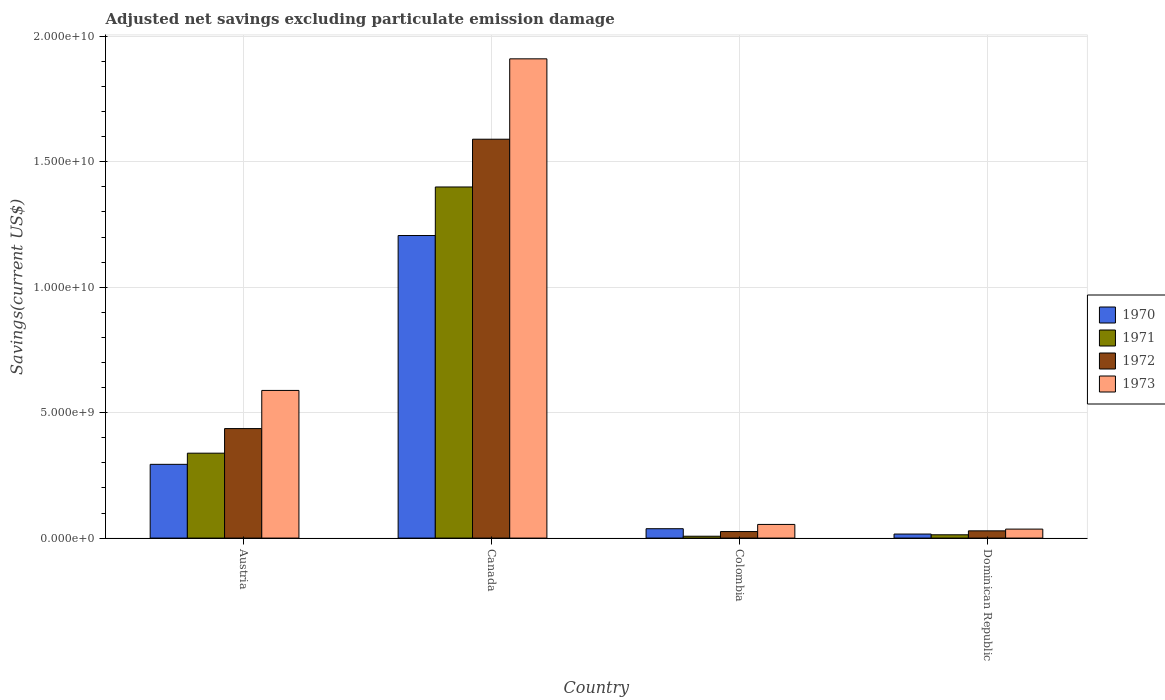How many bars are there on the 2nd tick from the right?
Ensure brevity in your answer.  4. What is the label of the 4th group of bars from the left?
Offer a very short reply. Dominican Republic. In how many cases, is the number of bars for a given country not equal to the number of legend labels?
Offer a terse response. 0. What is the adjusted net savings in 1970 in Dominican Republic?
Ensure brevity in your answer.  1.61e+08. Across all countries, what is the maximum adjusted net savings in 1972?
Your answer should be very brief. 1.59e+1. Across all countries, what is the minimum adjusted net savings in 1972?
Give a very brief answer. 2.60e+08. In which country was the adjusted net savings in 1972 maximum?
Keep it short and to the point. Canada. What is the total adjusted net savings in 1970 in the graph?
Provide a short and direct response. 1.55e+1. What is the difference between the adjusted net savings in 1971 in Canada and that in Colombia?
Your answer should be very brief. 1.39e+1. What is the difference between the adjusted net savings in 1970 in Canada and the adjusted net savings in 1972 in Dominican Republic?
Offer a terse response. 1.18e+1. What is the average adjusted net savings in 1973 per country?
Your answer should be compact. 6.47e+09. What is the difference between the adjusted net savings of/in 1970 and adjusted net savings of/in 1973 in Austria?
Keep it short and to the point. -2.95e+09. In how many countries, is the adjusted net savings in 1972 greater than 1000000000 US$?
Offer a terse response. 2. What is the ratio of the adjusted net savings in 1973 in Colombia to that in Dominican Republic?
Provide a succinct answer. 1.52. Is the adjusted net savings in 1972 in Colombia less than that in Dominican Republic?
Give a very brief answer. Yes. Is the difference between the adjusted net savings in 1970 in Canada and Dominican Republic greater than the difference between the adjusted net savings in 1973 in Canada and Dominican Republic?
Provide a succinct answer. No. What is the difference between the highest and the second highest adjusted net savings in 1972?
Offer a terse response. 4.08e+09. What is the difference between the highest and the lowest adjusted net savings in 1971?
Your answer should be compact. 1.39e+1. In how many countries, is the adjusted net savings in 1971 greater than the average adjusted net savings in 1971 taken over all countries?
Make the answer very short. 1. Is the sum of the adjusted net savings in 1970 in Canada and Colombia greater than the maximum adjusted net savings in 1971 across all countries?
Your answer should be compact. No. What does the 4th bar from the left in Colombia represents?
Your answer should be compact. 1973. What does the 2nd bar from the right in Dominican Republic represents?
Offer a terse response. 1972. How many bars are there?
Your answer should be very brief. 16. Are all the bars in the graph horizontal?
Provide a succinct answer. No. Does the graph contain grids?
Keep it short and to the point. Yes. How many legend labels are there?
Your answer should be compact. 4. How are the legend labels stacked?
Provide a short and direct response. Vertical. What is the title of the graph?
Offer a very short reply. Adjusted net savings excluding particulate emission damage. What is the label or title of the Y-axis?
Ensure brevity in your answer.  Savings(current US$). What is the Savings(current US$) of 1970 in Austria?
Provide a short and direct response. 2.94e+09. What is the Savings(current US$) in 1971 in Austria?
Your answer should be very brief. 3.38e+09. What is the Savings(current US$) of 1972 in Austria?
Provide a short and direct response. 4.37e+09. What is the Savings(current US$) of 1973 in Austria?
Give a very brief answer. 5.89e+09. What is the Savings(current US$) of 1970 in Canada?
Provide a short and direct response. 1.21e+1. What is the Savings(current US$) of 1971 in Canada?
Make the answer very short. 1.40e+1. What is the Savings(current US$) in 1972 in Canada?
Your answer should be very brief. 1.59e+1. What is the Savings(current US$) of 1973 in Canada?
Give a very brief answer. 1.91e+1. What is the Savings(current US$) in 1970 in Colombia?
Ensure brevity in your answer.  3.74e+08. What is the Savings(current US$) of 1971 in Colombia?
Ensure brevity in your answer.  7.46e+07. What is the Savings(current US$) in 1972 in Colombia?
Offer a very short reply. 2.60e+08. What is the Savings(current US$) of 1973 in Colombia?
Your response must be concise. 5.45e+08. What is the Savings(current US$) in 1970 in Dominican Republic?
Your response must be concise. 1.61e+08. What is the Savings(current US$) of 1971 in Dominican Republic?
Keep it short and to the point. 1.32e+08. What is the Savings(current US$) in 1972 in Dominican Republic?
Your answer should be very brief. 2.89e+08. What is the Savings(current US$) in 1973 in Dominican Republic?
Make the answer very short. 3.58e+08. Across all countries, what is the maximum Savings(current US$) in 1970?
Provide a succinct answer. 1.21e+1. Across all countries, what is the maximum Savings(current US$) in 1971?
Provide a short and direct response. 1.40e+1. Across all countries, what is the maximum Savings(current US$) in 1972?
Ensure brevity in your answer.  1.59e+1. Across all countries, what is the maximum Savings(current US$) in 1973?
Your answer should be compact. 1.91e+1. Across all countries, what is the minimum Savings(current US$) in 1970?
Keep it short and to the point. 1.61e+08. Across all countries, what is the minimum Savings(current US$) in 1971?
Offer a terse response. 7.46e+07. Across all countries, what is the minimum Savings(current US$) of 1972?
Your answer should be very brief. 2.60e+08. Across all countries, what is the minimum Savings(current US$) of 1973?
Provide a succinct answer. 3.58e+08. What is the total Savings(current US$) in 1970 in the graph?
Provide a succinct answer. 1.55e+1. What is the total Savings(current US$) in 1971 in the graph?
Make the answer very short. 1.76e+1. What is the total Savings(current US$) in 1972 in the graph?
Offer a very short reply. 2.08e+1. What is the total Savings(current US$) in 1973 in the graph?
Your answer should be compact. 2.59e+1. What is the difference between the Savings(current US$) in 1970 in Austria and that in Canada?
Your response must be concise. -9.12e+09. What is the difference between the Savings(current US$) in 1971 in Austria and that in Canada?
Give a very brief answer. -1.06e+1. What is the difference between the Savings(current US$) of 1972 in Austria and that in Canada?
Ensure brevity in your answer.  -1.15e+1. What is the difference between the Savings(current US$) in 1973 in Austria and that in Canada?
Make the answer very short. -1.32e+1. What is the difference between the Savings(current US$) in 1970 in Austria and that in Colombia?
Offer a terse response. 2.57e+09. What is the difference between the Savings(current US$) of 1971 in Austria and that in Colombia?
Offer a very short reply. 3.31e+09. What is the difference between the Savings(current US$) of 1972 in Austria and that in Colombia?
Make the answer very short. 4.11e+09. What is the difference between the Savings(current US$) of 1973 in Austria and that in Colombia?
Keep it short and to the point. 5.34e+09. What is the difference between the Savings(current US$) in 1970 in Austria and that in Dominican Republic?
Give a very brief answer. 2.78e+09. What is the difference between the Savings(current US$) in 1971 in Austria and that in Dominican Republic?
Provide a succinct answer. 3.25e+09. What is the difference between the Savings(current US$) in 1972 in Austria and that in Dominican Republic?
Keep it short and to the point. 4.08e+09. What is the difference between the Savings(current US$) of 1973 in Austria and that in Dominican Republic?
Provide a short and direct response. 5.53e+09. What is the difference between the Savings(current US$) of 1970 in Canada and that in Colombia?
Ensure brevity in your answer.  1.17e+1. What is the difference between the Savings(current US$) of 1971 in Canada and that in Colombia?
Make the answer very short. 1.39e+1. What is the difference between the Savings(current US$) in 1972 in Canada and that in Colombia?
Your answer should be very brief. 1.56e+1. What is the difference between the Savings(current US$) in 1973 in Canada and that in Colombia?
Keep it short and to the point. 1.86e+1. What is the difference between the Savings(current US$) of 1970 in Canada and that in Dominican Republic?
Your response must be concise. 1.19e+1. What is the difference between the Savings(current US$) of 1971 in Canada and that in Dominican Republic?
Ensure brevity in your answer.  1.39e+1. What is the difference between the Savings(current US$) of 1972 in Canada and that in Dominican Republic?
Provide a short and direct response. 1.56e+1. What is the difference between the Savings(current US$) of 1973 in Canada and that in Dominican Republic?
Your response must be concise. 1.87e+1. What is the difference between the Savings(current US$) in 1970 in Colombia and that in Dominican Republic?
Make the answer very short. 2.13e+08. What is the difference between the Savings(current US$) in 1971 in Colombia and that in Dominican Republic?
Your answer should be very brief. -5.69e+07. What is the difference between the Savings(current US$) in 1972 in Colombia and that in Dominican Republic?
Provide a short and direct response. -2.84e+07. What is the difference between the Savings(current US$) of 1973 in Colombia and that in Dominican Republic?
Offer a very short reply. 1.87e+08. What is the difference between the Savings(current US$) of 1970 in Austria and the Savings(current US$) of 1971 in Canada?
Keep it short and to the point. -1.11e+1. What is the difference between the Savings(current US$) of 1970 in Austria and the Savings(current US$) of 1972 in Canada?
Your response must be concise. -1.30e+1. What is the difference between the Savings(current US$) of 1970 in Austria and the Savings(current US$) of 1973 in Canada?
Give a very brief answer. -1.62e+1. What is the difference between the Savings(current US$) in 1971 in Austria and the Savings(current US$) in 1972 in Canada?
Your response must be concise. -1.25e+1. What is the difference between the Savings(current US$) in 1971 in Austria and the Savings(current US$) in 1973 in Canada?
Keep it short and to the point. -1.57e+1. What is the difference between the Savings(current US$) of 1972 in Austria and the Savings(current US$) of 1973 in Canada?
Offer a terse response. -1.47e+1. What is the difference between the Savings(current US$) of 1970 in Austria and the Savings(current US$) of 1971 in Colombia?
Make the answer very short. 2.87e+09. What is the difference between the Savings(current US$) in 1970 in Austria and the Savings(current US$) in 1972 in Colombia?
Keep it short and to the point. 2.68e+09. What is the difference between the Savings(current US$) of 1970 in Austria and the Savings(current US$) of 1973 in Colombia?
Keep it short and to the point. 2.40e+09. What is the difference between the Savings(current US$) of 1971 in Austria and the Savings(current US$) of 1972 in Colombia?
Offer a very short reply. 3.12e+09. What is the difference between the Savings(current US$) of 1971 in Austria and the Savings(current US$) of 1973 in Colombia?
Keep it short and to the point. 2.84e+09. What is the difference between the Savings(current US$) in 1972 in Austria and the Savings(current US$) in 1973 in Colombia?
Your answer should be very brief. 3.82e+09. What is the difference between the Savings(current US$) in 1970 in Austria and the Savings(current US$) in 1971 in Dominican Republic?
Your answer should be very brief. 2.81e+09. What is the difference between the Savings(current US$) in 1970 in Austria and the Savings(current US$) in 1972 in Dominican Republic?
Your answer should be very brief. 2.65e+09. What is the difference between the Savings(current US$) of 1970 in Austria and the Savings(current US$) of 1973 in Dominican Republic?
Provide a succinct answer. 2.58e+09. What is the difference between the Savings(current US$) of 1971 in Austria and the Savings(current US$) of 1972 in Dominican Republic?
Offer a very short reply. 3.10e+09. What is the difference between the Savings(current US$) of 1971 in Austria and the Savings(current US$) of 1973 in Dominican Republic?
Offer a very short reply. 3.03e+09. What is the difference between the Savings(current US$) of 1972 in Austria and the Savings(current US$) of 1973 in Dominican Republic?
Provide a short and direct response. 4.01e+09. What is the difference between the Savings(current US$) in 1970 in Canada and the Savings(current US$) in 1971 in Colombia?
Keep it short and to the point. 1.20e+1. What is the difference between the Savings(current US$) in 1970 in Canada and the Savings(current US$) in 1972 in Colombia?
Provide a short and direct response. 1.18e+1. What is the difference between the Savings(current US$) of 1970 in Canada and the Savings(current US$) of 1973 in Colombia?
Provide a succinct answer. 1.15e+1. What is the difference between the Savings(current US$) of 1971 in Canada and the Savings(current US$) of 1972 in Colombia?
Your response must be concise. 1.37e+1. What is the difference between the Savings(current US$) of 1971 in Canada and the Savings(current US$) of 1973 in Colombia?
Provide a succinct answer. 1.35e+1. What is the difference between the Savings(current US$) in 1972 in Canada and the Savings(current US$) in 1973 in Colombia?
Your answer should be compact. 1.54e+1. What is the difference between the Savings(current US$) of 1970 in Canada and the Savings(current US$) of 1971 in Dominican Republic?
Ensure brevity in your answer.  1.19e+1. What is the difference between the Savings(current US$) of 1970 in Canada and the Savings(current US$) of 1972 in Dominican Republic?
Provide a succinct answer. 1.18e+1. What is the difference between the Savings(current US$) of 1970 in Canada and the Savings(current US$) of 1973 in Dominican Republic?
Your answer should be compact. 1.17e+1. What is the difference between the Savings(current US$) of 1971 in Canada and the Savings(current US$) of 1972 in Dominican Republic?
Your answer should be very brief. 1.37e+1. What is the difference between the Savings(current US$) in 1971 in Canada and the Savings(current US$) in 1973 in Dominican Republic?
Ensure brevity in your answer.  1.36e+1. What is the difference between the Savings(current US$) of 1972 in Canada and the Savings(current US$) of 1973 in Dominican Republic?
Your answer should be very brief. 1.55e+1. What is the difference between the Savings(current US$) of 1970 in Colombia and the Savings(current US$) of 1971 in Dominican Republic?
Give a very brief answer. 2.42e+08. What is the difference between the Savings(current US$) in 1970 in Colombia and the Savings(current US$) in 1972 in Dominican Republic?
Ensure brevity in your answer.  8.52e+07. What is the difference between the Savings(current US$) in 1970 in Colombia and the Savings(current US$) in 1973 in Dominican Republic?
Keep it short and to the point. 1.57e+07. What is the difference between the Savings(current US$) of 1971 in Colombia and the Savings(current US$) of 1972 in Dominican Republic?
Make the answer very short. -2.14e+08. What is the difference between the Savings(current US$) of 1971 in Colombia and the Savings(current US$) of 1973 in Dominican Republic?
Your answer should be very brief. -2.84e+08. What is the difference between the Savings(current US$) in 1972 in Colombia and the Savings(current US$) in 1973 in Dominican Republic?
Offer a terse response. -9.79e+07. What is the average Savings(current US$) of 1970 per country?
Provide a succinct answer. 3.88e+09. What is the average Savings(current US$) of 1971 per country?
Provide a succinct answer. 4.40e+09. What is the average Savings(current US$) in 1972 per country?
Offer a terse response. 5.20e+09. What is the average Savings(current US$) of 1973 per country?
Your answer should be compact. 6.47e+09. What is the difference between the Savings(current US$) of 1970 and Savings(current US$) of 1971 in Austria?
Keep it short and to the point. -4.45e+08. What is the difference between the Savings(current US$) of 1970 and Savings(current US$) of 1972 in Austria?
Provide a short and direct response. -1.43e+09. What is the difference between the Savings(current US$) in 1970 and Savings(current US$) in 1973 in Austria?
Offer a terse response. -2.95e+09. What is the difference between the Savings(current US$) of 1971 and Savings(current US$) of 1972 in Austria?
Make the answer very short. -9.81e+08. What is the difference between the Savings(current US$) in 1971 and Savings(current US$) in 1973 in Austria?
Provide a succinct answer. -2.50e+09. What is the difference between the Savings(current US$) of 1972 and Savings(current US$) of 1973 in Austria?
Your response must be concise. -1.52e+09. What is the difference between the Savings(current US$) of 1970 and Savings(current US$) of 1971 in Canada?
Your answer should be compact. -1.94e+09. What is the difference between the Savings(current US$) in 1970 and Savings(current US$) in 1972 in Canada?
Offer a terse response. -3.84e+09. What is the difference between the Savings(current US$) of 1970 and Savings(current US$) of 1973 in Canada?
Your answer should be compact. -7.04e+09. What is the difference between the Savings(current US$) of 1971 and Savings(current US$) of 1972 in Canada?
Give a very brief answer. -1.90e+09. What is the difference between the Savings(current US$) in 1971 and Savings(current US$) in 1973 in Canada?
Ensure brevity in your answer.  -5.11e+09. What is the difference between the Savings(current US$) of 1972 and Savings(current US$) of 1973 in Canada?
Offer a very short reply. -3.20e+09. What is the difference between the Savings(current US$) in 1970 and Savings(current US$) in 1971 in Colombia?
Provide a short and direct response. 2.99e+08. What is the difference between the Savings(current US$) in 1970 and Savings(current US$) in 1972 in Colombia?
Give a very brief answer. 1.14e+08. What is the difference between the Savings(current US$) of 1970 and Savings(current US$) of 1973 in Colombia?
Make the answer very short. -1.71e+08. What is the difference between the Savings(current US$) of 1971 and Savings(current US$) of 1972 in Colombia?
Your answer should be very brief. -1.86e+08. What is the difference between the Savings(current US$) of 1971 and Savings(current US$) of 1973 in Colombia?
Offer a terse response. -4.70e+08. What is the difference between the Savings(current US$) in 1972 and Savings(current US$) in 1973 in Colombia?
Your answer should be compact. -2.85e+08. What is the difference between the Savings(current US$) in 1970 and Savings(current US$) in 1971 in Dominican Republic?
Offer a very short reply. 2.96e+07. What is the difference between the Savings(current US$) of 1970 and Savings(current US$) of 1972 in Dominican Republic?
Make the answer very short. -1.28e+08. What is the difference between the Savings(current US$) of 1970 and Savings(current US$) of 1973 in Dominican Republic?
Offer a terse response. -1.97e+08. What is the difference between the Savings(current US$) of 1971 and Savings(current US$) of 1972 in Dominican Republic?
Your answer should be compact. -1.57e+08. What is the difference between the Savings(current US$) of 1971 and Savings(current US$) of 1973 in Dominican Republic?
Your answer should be very brief. -2.27e+08. What is the difference between the Savings(current US$) of 1972 and Savings(current US$) of 1973 in Dominican Republic?
Keep it short and to the point. -6.95e+07. What is the ratio of the Savings(current US$) of 1970 in Austria to that in Canada?
Your answer should be very brief. 0.24. What is the ratio of the Savings(current US$) in 1971 in Austria to that in Canada?
Your answer should be compact. 0.24. What is the ratio of the Savings(current US$) in 1972 in Austria to that in Canada?
Keep it short and to the point. 0.27. What is the ratio of the Savings(current US$) in 1973 in Austria to that in Canada?
Your answer should be very brief. 0.31. What is the ratio of the Savings(current US$) in 1970 in Austria to that in Colombia?
Offer a very short reply. 7.86. What is the ratio of the Savings(current US$) of 1971 in Austria to that in Colombia?
Provide a succinct answer. 45.37. What is the ratio of the Savings(current US$) in 1972 in Austria to that in Colombia?
Provide a succinct answer. 16.77. What is the ratio of the Savings(current US$) in 1973 in Austria to that in Colombia?
Your answer should be compact. 10.8. What is the ratio of the Savings(current US$) of 1970 in Austria to that in Dominican Republic?
Your answer should be very brief. 18.25. What is the ratio of the Savings(current US$) of 1971 in Austria to that in Dominican Republic?
Your answer should be very brief. 25.73. What is the ratio of the Savings(current US$) of 1972 in Austria to that in Dominican Republic?
Offer a very short reply. 15.12. What is the ratio of the Savings(current US$) of 1973 in Austria to that in Dominican Republic?
Your response must be concise. 16.43. What is the ratio of the Savings(current US$) in 1970 in Canada to that in Colombia?
Your response must be concise. 32.26. What is the ratio of the Savings(current US$) of 1971 in Canada to that in Colombia?
Give a very brief answer. 187.59. What is the ratio of the Savings(current US$) in 1972 in Canada to that in Colombia?
Provide a short and direct response. 61.09. What is the ratio of the Savings(current US$) in 1973 in Canada to that in Colombia?
Keep it short and to the point. 35.07. What is the ratio of the Savings(current US$) of 1970 in Canada to that in Dominican Republic?
Keep it short and to the point. 74.87. What is the ratio of the Savings(current US$) of 1971 in Canada to that in Dominican Republic?
Offer a terse response. 106.4. What is the ratio of the Savings(current US$) of 1972 in Canada to that in Dominican Republic?
Your response must be concise. 55.08. What is the ratio of the Savings(current US$) of 1973 in Canada to that in Dominican Republic?
Offer a terse response. 53.33. What is the ratio of the Savings(current US$) of 1970 in Colombia to that in Dominican Republic?
Your response must be concise. 2.32. What is the ratio of the Savings(current US$) of 1971 in Colombia to that in Dominican Republic?
Offer a terse response. 0.57. What is the ratio of the Savings(current US$) in 1972 in Colombia to that in Dominican Republic?
Keep it short and to the point. 0.9. What is the ratio of the Savings(current US$) of 1973 in Colombia to that in Dominican Republic?
Provide a succinct answer. 1.52. What is the difference between the highest and the second highest Savings(current US$) of 1970?
Keep it short and to the point. 9.12e+09. What is the difference between the highest and the second highest Savings(current US$) in 1971?
Make the answer very short. 1.06e+1. What is the difference between the highest and the second highest Savings(current US$) of 1972?
Provide a short and direct response. 1.15e+1. What is the difference between the highest and the second highest Savings(current US$) of 1973?
Your answer should be very brief. 1.32e+1. What is the difference between the highest and the lowest Savings(current US$) of 1970?
Provide a short and direct response. 1.19e+1. What is the difference between the highest and the lowest Savings(current US$) in 1971?
Your answer should be very brief. 1.39e+1. What is the difference between the highest and the lowest Savings(current US$) of 1972?
Your response must be concise. 1.56e+1. What is the difference between the highest and the lowest Savings(current US$) of 1973?
Provide a short and direct response. 1.87e+1. 